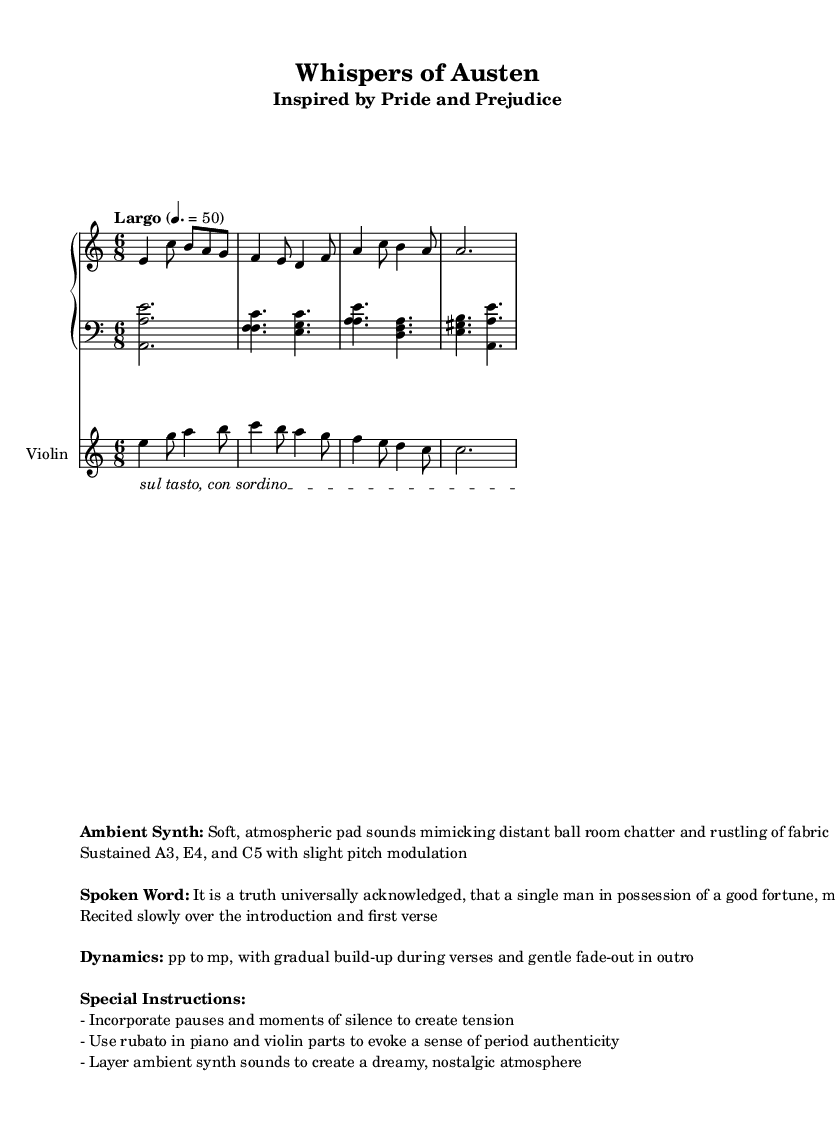What is the key signature of this music? The key signature is A minor, indicated by the presence of one sharp (G#) and the absence of any flats.
Answer: A minor What is the time signature of this music? The time signature is 6/8, which can be determined by the "6/8" notation found at the beginning of the score. This indicates that there are six eighth notes in each measure.
Answer: 6/8 What is the tempo marking for this piece? The tempo marking is marked as "Largo" with a metronome indication of 50 beats per minute, suggesting a slow tempo. This is specified in the tempo direction just after the time signature.
Answer: Largo, 50 What is the specific instruction given for the violin performance? The specific instruction for the violin is "sul tasto, con sordino", which indicates that the player should use the bow near the fingerboard and play with a mute to create a softer sound quality. This instruction is found in the text spanner on the violin staff.
Answer: sul tasto, con sordino How many staves are used for the piano part? There are two staves used for the piano part, one for the right hand and one for the left hand, as indicated by the PianoStaff notation.
Answer: Two What kind of ambient sounds are suggested for this piece? The suggested ambient sounds include soft, atmospheric pad sounds that mimic distant ballroom chatter and the rustling of fabric. This information is detailed under "Ambient Synth" in the markup section.
Answer: Soft, atmospheric pad sounds What dynamics are indicated for this composition? The dynamics indicated for this composition range from pp (pianissimo) to mp (mezzo-piano), with a gradual build-up during verses. This is noted in the dynamics section of the markup.
Answer: pp to mp 